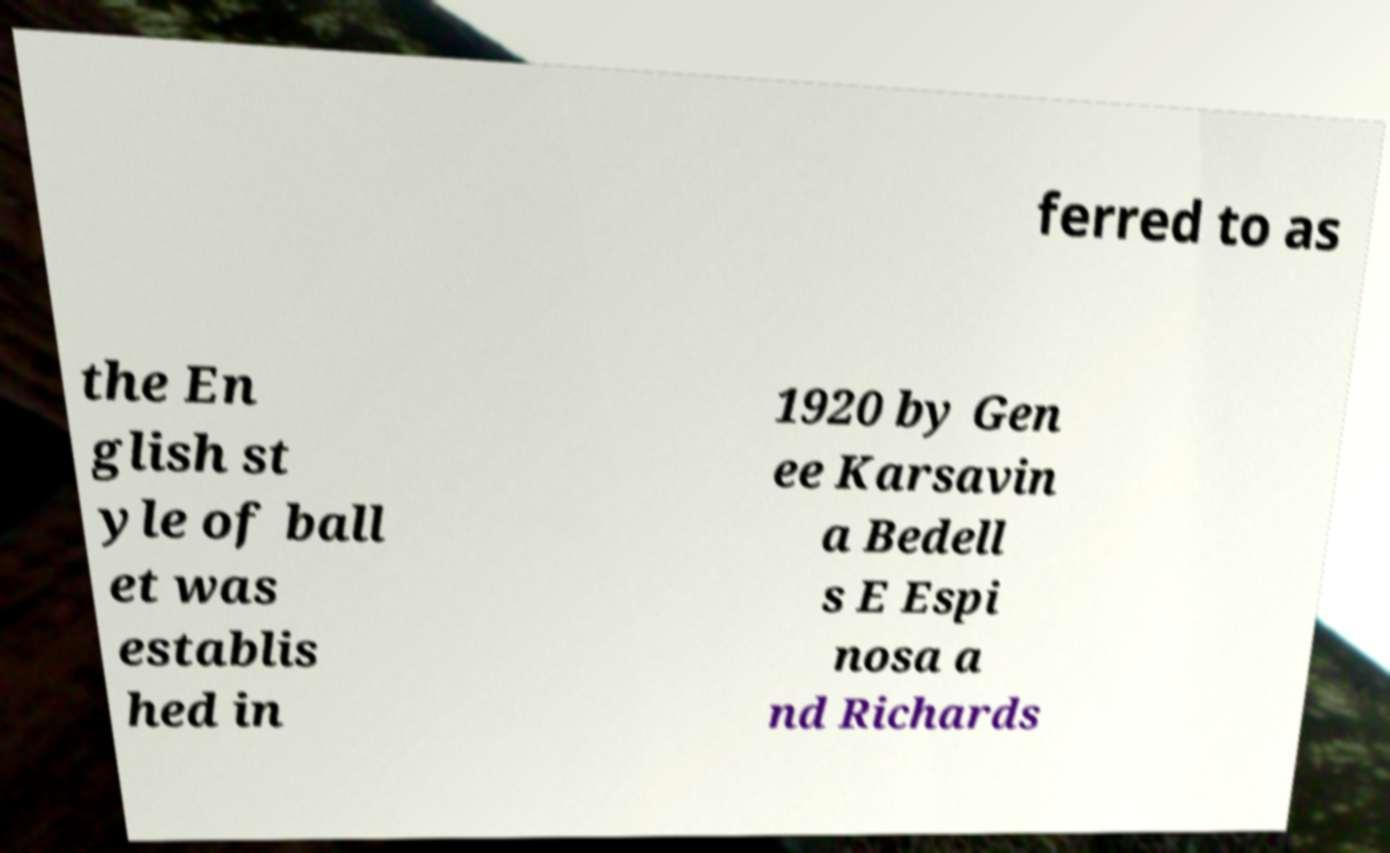For documentation purposes, I need the text within this image transcribed. Could you provide that? ferred to as the En glish st yle of ball et was establis hed in 1920 by Gen ee Karsavin a Bedell s E Espi nosa a nd Richards 